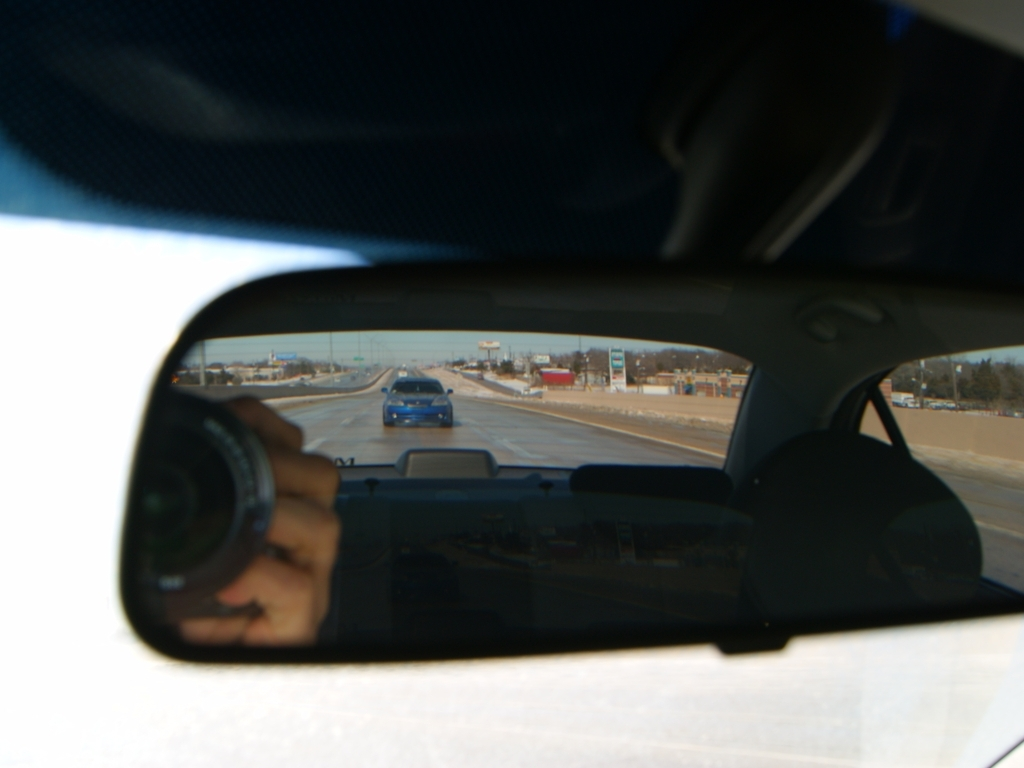What does the inclusion of certain elements in the rearview mirror tell you about the photographer's intention? The careful framing to include the camera lens in the rearview mirror suggests a meta-commentary on observation and being observed. It appears the photographer wants viewers to reflect on the act of watching and being watched, symbolically using the rearview mirror as a tool for deeper introspection about perspective and reality. How does the scenery outside contribute to the overall mood of the photo? The outward scenery, featuring a clear blue sky and other vehicles on a broad road, evokes a sense of daily travel and routine. It injects a mundane but relatable backdrop that contrasts with the more focused and introspective mood created by the rearview mirror's reflection. 